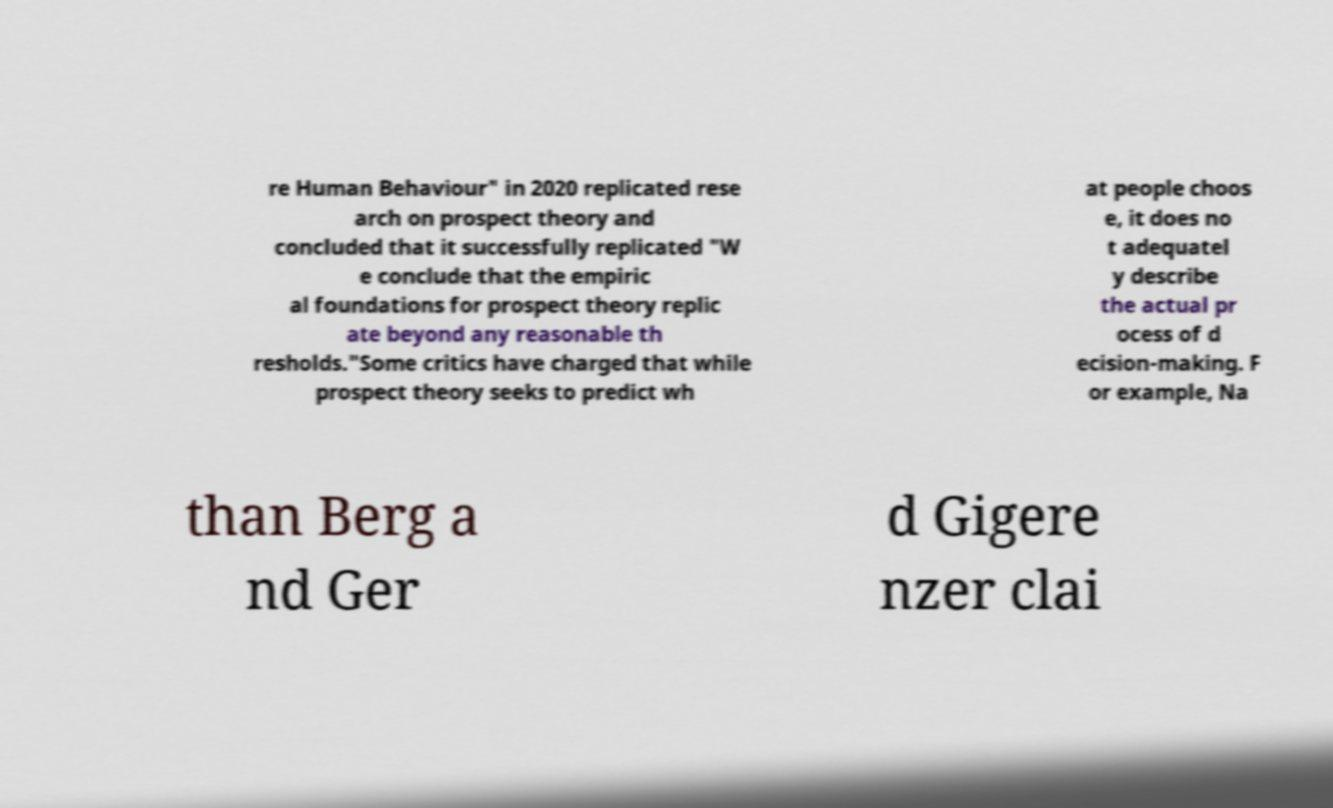I need the written content from this picture converted into text. Can you do that? re Human Behaviour" in 2020 replicated rese arch on prospect theory and concluded that it successfully replicated "W e conclude that the empiric al foundations for prospect theory replic ate beyond any reasonable th resholds."Some critics have charged that while prospect theory seeks to predict wh at people choos e, it does no t adequatel y describe the actual pr ocess of d ecision-making. F or example, Na than Berg a nd Ger d Gigere nzer clai 